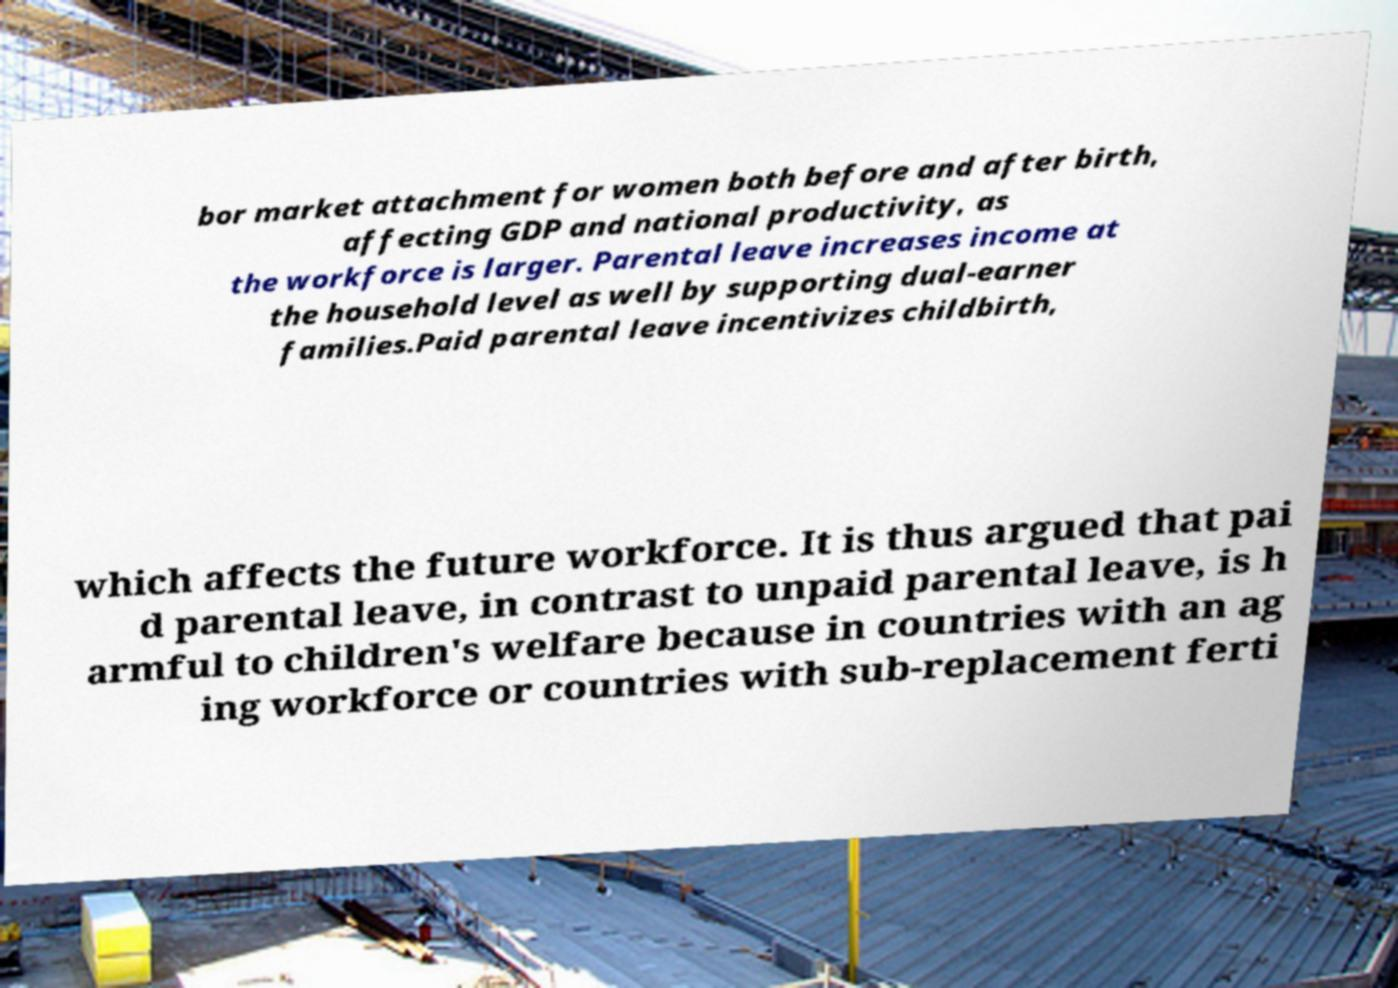For documentation purposes, I need the text within this image transcribed. Could you provide that? bor market attachment for women both before and after birth, affecting GDP and national productivity, as the workforce is larger. Parental leave increases income at the household level as well by supporting dual-earner families.Paid parental leave incentivizes childbirth, which affects the future workforce. It is thus argued that pai d parental leave, in contrast to unpaid parental leave, is h armful to children's welfare because in countries with an ag ing workforce or countries with sub-replacement ferti 